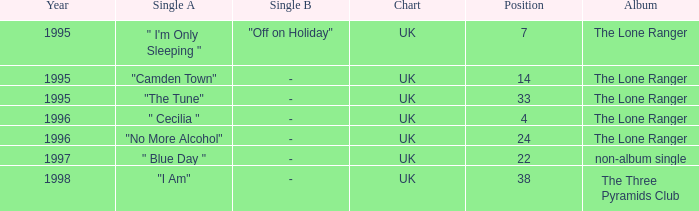After 1996, what is the average position? 30.0. 